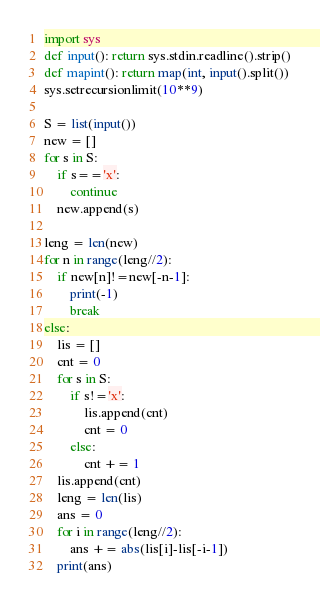Convert code to text. <code><loc_0><loc_0><loc_500><loc_500><_Python_>import sys
def input(): return sys.stdin.readline().strip()
def mapint(): return map(int, input().split())
sys.setrecursionlimit(10**9)

S = list(input())
new = []
for s in S:
    if s=='x':
        continue
    new.append(s)

leng = len(new)
for n in range(leng//2):
    if new[n]!=new[-n-1]:
        print(-1)
        break
else:
    lis = []
    cnt = 0
    for s in S:
        if s!='x':
            lis.append(cnt)
            cnt = 0
        else:
            cnt += 1
    lis.append(cnt)
    leng = len(lis)
    ans = 0
    for i in range(leng//2):
        ans += abs(lis[i]-lis[-i-1])
    print(ans)</code> 